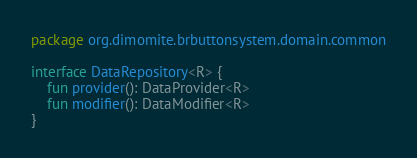<code> <loc_0><loc_0><loc_500><loc_500><_Kotlin_>package org.dimomite.brbuttonsystem.domain.common

interface DataRepository<R> {
    fun provider(): DataProvider<R>
    fun modifier(): DataModifier<R>
}
</code> 